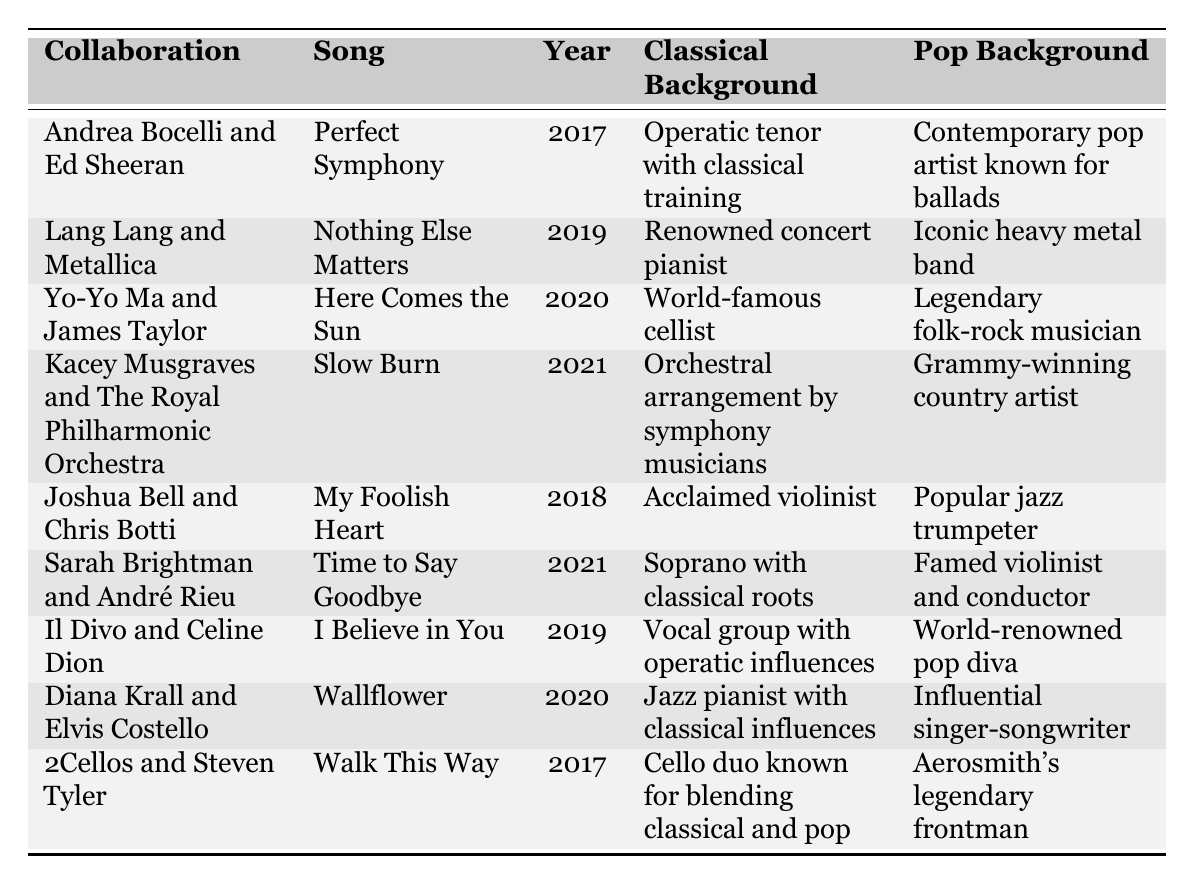What year was the collaboration between Andrea Bocelli and Ed Sheeran? The table lists the year of collaboration between Andrea Bocelli and Ed Sheeran, which is 2017.
Answer: 2017 Who collaborated with Metallica in 2019? The table shows that Lang Lang collaborated with Metallica in 2019.
Answer: Lang Lang How many collaborations featured artists from the pop genre in 2020? The table lists three collaborations in 2020: Yo-Yo Ma and James Taylor, Kacey Musgraves and The Royal Philharmonic Orchestra, and Diana Krall and Elvis Costello. Thus, the answer is 3.
Answer: 3 What is the classical background of Diana Krall's collaboration? According to the table, Diana Krall's classical background is described as a jazz pianist with classical influences.
Answer: Jazz pianist with classical influences In which year did both the collaboration of "Slow Burn" and "Time to Say Goodbye" occur? The collaborations of "Slow Burn" and "Time to Say Goodbye" both occurred in 2021, as listed in the table.
Answer: 2021 Is Sarah Brightman partnered with a classical musician in her collaboration? The table indicates that Sarah Brightman collaborated with André Rieu, who is described as a famed violinist and conductor, thus confirming a partnership with a classical musician.
Answer: Yes Which collaboration involved a cello duo blending classical and pop? The table identifies the collaboration "Walk This Way" by 2Cellos and Steven Tyler as featuring a cello duo known for blending classical and pop.
Answer: Walk This Way What is the difference in years between the earliest and latest collaborations shown? The earliest collaboration is from 2017 and the latest is from 2021. The difference is calculated as 2021 - 2017 = 4 years.
Answer: 4 years How many collaborations did Kacey Musgraves take part in according to the table? The table indicates that Kacey Musgraves was involved in one collaboration, which is with The Royal Philharmonic Orchestra for the song "Slow Burn."
Answer: 1 Which pop artist collaborated with a world-renowned pop diva? The table reveals that Celine Dion collaborated with Il Divo, which is described as a vocal group with operatic influences and is paired with the pop background of a world-renowned pop diva.
Answer: Il Divo and Celine Dion 